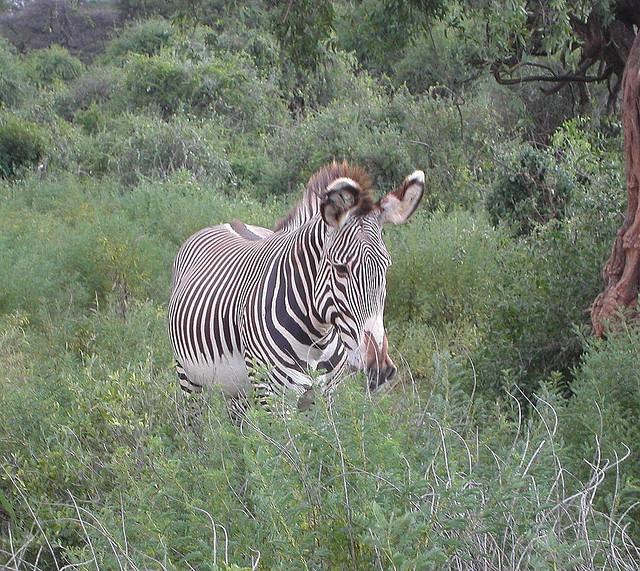Which animal is this?
Write a very short answer. Zebra. Does the zebra have plenty of grass to eat?
Short answer required. Yes. Is this animal in a zoo?
Concise answer only. No. 